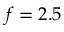Convert formula to latex. <formula><loc_0><loc_0><loc_500><loc_500>f = 2 . 5</formula> 